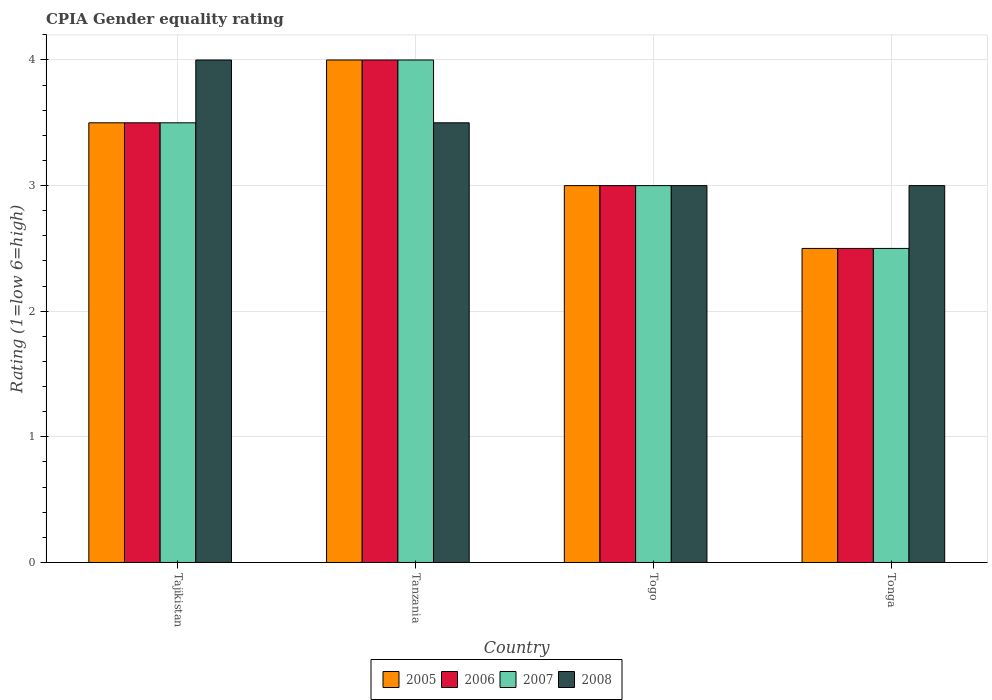How many groups of bars are there?
Give a very brief answer. 4. Are the number of bars per tick equal to the number of legend labels?
Ensure brevity in your answer.  Yes. Are the number of bars on each tick of the X-axis equal?
Your answer should be compact. Yes. How many bars are there on the 3rd tick from the left?
Your answer should be very brief. 4. What is the label of the 3rd group of bars from the left?
Your answer should be compact. Togo. What is the CPIA rating in 2006 in Togo?
Offer a very short reply. 3. Across all countries, what is the minimum CPIA rating in 2007?
Your answer should be very brief. 2.5. In which country was the CPIA rating in 2007 maximum?
Provide a short and direct response. Tanzania. In which country was the CPIA rating in 2005 minimum?
Your answer should be compact. Tonga. What is the difference between the CPIA rating in 2005 in Tajikistan and that in Tanzania?
Make the answer very short. -0.5. What is the average CPIA rating in 2008 per country?
Provide a short and direct response. 3.38. What is the difference between the CPIA rating of/in 2006 and CPIA rating of/in 2008 in Togo?
Your response must be concise. 0. In how many countries, is the CPIA rating in 2005 greater than 2.8?
Your response must be concise. 3. Is the difference between the CPIA rating in 2006 in Tajikistan and Tanzania greater than the difference between the CPIA rating in 2008 in Tajikistan and Tanzania?
Provide a succinct answer. No. What is the difference between the highest and the second highest CPIA rating in 2005?
Offer a terse response. -0.5. In how many countries, is the CPIA rating in 2007 greater than the average CPIA rating in 2007 taken over all countries?
Your answer should be very brief. 2. Is the sum of the CPIA rating in 2005 in Tanzania and Tonga greater than the maximum CPIA rating in 2007 across all countries?
Offer a very short reply. Yes. Is it the case that in every country, the sum of the CPIA rating in 2008 and CPIA rating in 2007 is greater than the sum of CPIA rating in 2005 and CPIA rating in 2006?
Keep it short and to the point. No. What does the 2nd bar from the left in Tanzania represents?
Keep it short and to the point. 2006. What does the 1st bar from the right in Tonga represents?
Provide a short and direct response. 2008. How many bars are there?
Give a very brief answer. 16. How many countries are there in the graph?
Offer a very short reply. 4. What is the difference between two consecutive major ticks on the Y-axis?
Make the answer very short. 1. Are the values on the major ticks of Y-axis written in scientific E-notation?
Offer a very short reply. No. Does the graph contain any zero values?
Your response must be concise. No. What is the title of the graph?
Give a very brief answer. CPIA Gender equality rating. Does "1989" appear as one of the legend labels in the graph?
Give a very brief answer. No. What is the label or title of the X-axis?
Your response must be concise. Country. What is the Rating (1=low 6=high) in 2005 in Tajikistan?
Your answer should be compact. 3.5. What is the Rating (1=low 6=high) in 2008 in Tajikistan?
Keep it short and to the point. 4. What is the Rating (1=low 6=high) in 2005 in Tanzania?
Keep it short and to the point. 4. What is the Rating (1=low 6=high) in 2007 in Tanzania?
Offer a terse response. 4. What is the Rating (1=low 6=high) in 2005 in Tonga?
Your answer should be compact. 2.5. What is the Rating (1=low 6=high) of 2008 in Tonga?
Ensure brevity in your answer.  3. Across all countries, what is the maximum Rating (1=low 6=high) in 2005?
Offer a very short reply. 4. Across all countries, what is the maximum Rating (1=low 6=high) of 2007?
Make the answer very short. 4. Across all countries, what is the maximum Rating (1=low 6=high) in 2008?
Make the answer very short. 4. Across all countries, what is the minimum Rating (1=low 6=high) in 2005?
Provide a succinct answer. 2.5. Across all countries, what is the minimum Rating (1=low 6=high) of 2006?
Ensure brevity in your answer.  2.5. Across all countries, what is the minimum Rating (1=low 6=high) of 2007?
Provide a succinct answer. 2.5. What is the total Rating (1=low 6=high) in 2005 in the graph?
Your answer should be compact. 13. What is the total Rating (1=low 6=high) in 2007 in the graph?
Give a very brief answer. 13. What is the difference between the Rating (1=low 6=high) in 2006 in Tajikistan and that in Tanzania?
Provide a succinct answer. -0.5. What is the difference between the Rating (1=low 6=high) of 2008 in Tajikistan and that in Tanzania?
Your answer should be compact. 0.5. What is the difference between the Rating (1=low 6=high) of 2005 in Tajikistan and that in Togo?
Provide a short and direct response. 0.5. What is the difference between the Rating (1=low 6=high) of 2006 in Tajikistan and that in Togo?
Provide a short and direct response. 0.5. What is the difference between the Rating (1=low 6=high) in 2007 in Tajikistan and that in Togo?
Your response must be concise. 0.5. What is the difference between the Rating (1=low 6=high) in 2008 in Tajikistan and that in Togo?
Your answer should be compact. 1. What is the difference between the Rating (1=low 6=high) in 2005 in Tajikistan and that in Tonga?
Offer a very short reply. 1. What is the difference between the Rating (1=low 6=high) in 2006 in Tajikistan and that in Tonga?
Give a very brief answer. 1. What is the difference between the Rating (1=low 6=high) in 2007 in Tajikistan and that in Tonga?
Ensure brevity in your answer.  1. What is the difference between the Rating (1=low 6=high) in 2008 in Tajikistan and that in Tonga?
Make the answer very short. 1. What is the difference between the Rating (1=low 6=high) in 2005 in Tanzania and that in Togo?
Offer a terse response. 1. What is the difference between the Rating (1=low 6=high) in 2006 in Tanzania and that in Togo?
Give a very brief answer. 1. What is the difference between the Rating (1=low 6=high) of 2007 in Tanzania and that in Togo?
Give a very brief answer. 1. What is the difference between the Rating (1=low 6=high) in 2008 in Tanzania and that in Togo?
Provide a succinct answer. 0.5. What is the difference between the Rating (1=low 6=high) of 2007 in Tanzania and that in Tonga?
Provide a short and direct response. 1.5. What is the difference between the Rating (1=low 6=high) of 2008 in Tanzania and that in Tonga?
Provide a short and direct response. 0.5. What is the difference between the Rating (1=low 6=high) of 2006 in Togo and that in Tonga?
Provide a succinct answer. 0.5. What is the difference between the Rating (1=low 6=high) in 2007 in Togo and that in Tonga?
Keep it short and to the point. 0.5. What is the difference between the Rating (1=low 6=high) in 2008 in Togo and that in Tonga?
Ensure brevity in your answer.  0. What is the difference between the Rating (1=low 6=high) of 2005 in Tajikistan and the Rating (1=low 6=high) of 2006 in Tanzania?
Ensure brevity in your answer.  -0.5. What is the difference between the Rating (1=low 6=high) in 2005 in Tajikistan and the Rating (1=low 6=high) in 2008 in Tanzania?
Provide a succinct answer. 0. What is the difference between the Rating (1=low 6=high) in 2006 in Tajikistan and the Rating (1=low 6=high) in 2008 in Tanzania?
Ensure brevity in your answer.  0. What is the difference between the Rating (1=low 6=high) in 2007 in Tajikistan and the Rating (1=low 6=high) in 2008 in Tanzania?
Provide a short and direct response. 0. What is the difference between the Rating (1=low 6=high) in 2005 in Tajikistan and the Rating (1=low 6=high) in 2008 in Togo?
Make the answer very short. 0.5. What is the difference between the Rating (1=low 6=high) of 2006 in Tajikistan and the Rating (1=low 6=high) of 2007 in Togo?
Your answer should be very brief. 0.5. What is the difference between the Rating (1=low 6=high) of 2006 in Tajikistan and the Rating (1=low 6=high) of 2008 in Togo?
Provide a short and direct response. 0.5. What is the difference between the Rating (1=low 6=high) of 2005 in Tajikistan and the Rating (1=low 6=high) of 2007 in Tonga?
Your response must be concise. 1. What is the difference between the Rating (1=low 6=high) of 2005 in Tajikistan and the Rating (1=low 6=high) of 2008 in Tonga?
Your answer should be compact. 0.5. What is the difference between the Rating (1=low 6=high) of 2006 in Tajikistan and the Rating (1=low 6=high) of 2008 in Tonga?
Provide a short and direct response. 0.5. What is the difference between the Rating (1=low 6=high) of 2007 in Tajikistan and the Rating (1=low 6=high) of 2008 in Tonga?
Keep it short and to the point. 0.5. What is the difference between the Rating (1=low 6=high) in 2005 in Tanzania and the Rating (1=low 6=high) in 2006 in Togo?
Your answer should be compact. 1. What is the difference between the Rating (1=low 6=high) of 2005 in Tanzania and the Rating (1=low 6=high) of 2007 in Togo?
Make the answer very short. 1. What is the difference between the Rating (1=low 6=high) in 2005 in Tanzania and the Rating (1=low 6=high) in 2008 in Togo?
Keep it short and to the point. 1. What is the difference between the Rating (1=low 6=high) of 2006 in Tanzania and the Rating (1=low 6=high) of 2008 in Togo?
Give a very brief answer. 1. What is the difference between the Rating (1=low 6=high) in 2007 in Tanzania and the Rating (1=low 6=high) in 2008 in Togo?
Provide a short and direct response. 1. What is the difference between the Rating (1=low 6=high) in 2005 in Tanzania and the Rating (1=low 6=high) in 2007 in Tonga?
Give a very brief answer. 1.5. What is the difference between the Rating (1=low 6=high) in 2005 in Tanzania and the Rating (1=low 6=high) in 2008 in Tonga?
Ensure brevity in your answer.  1. What is the difference between the Rating (1=low 6=high) of 2006 in Tanzania and the Rating (1=low 6=high) of 2008 in Tonga?
Keep it short and to the point. 1. What is the difference between the Rating (1=low 6=high) in 2007 in Tanzania and the Rating (1=low 6=high) in 2008 in Tonga?
Make the answer very short. 1. What is the difference between the Rating (1=low 6=high) of 2005 in Togo and the Rating (1=low 6=high) of 2006 in Tonga?
Offer a terse response. 0.5. What is the difference between the Rating (1=low 6=high) in 2006 in Togo and the Rating (1=low 6=high) in 2007 in Tonga?
Ensure brevity in your answer.  0.5. What is the difference between the Rating (1=low 6=high) in 2006 in Togo and the Rating (1=low 6=high) in 2008 in Tonga?
Ensure brevity in your answer.  0. What is the average Rating (1=low 6=high) in 2006 per country?
Your response must be concise. 3.25. What is the average Rating (1=low 6=high) in 2008 per country?
Keep it short and to the point. 3.38. What is the difference between the Rating (1=low 6=high) of 2006 and Rating (1=low 6=high) of 2007 in Tajikistan?
Offer a terse response. 0. What is the difference between the Rating (1=low 6=high) of 2007 and Rating (1=low 6=high) of 2008 in Tajikistan?
Your answer should be compact. -0.5. What is the difference between the Rating (1=low 6=high) of 2005 and Rating (1=low 6=high) of 2007 in Tanzania?
Ensure brevity in your answer.  0. What is the difference between the Rating (1=low 6=high) of 2006 and Rating (1=low 6=high) of 2007 in Togo?
Offer a terse response. 0. What is the difference between the Rating (1=low 6=high) of 2005 and Rating (1=low 6=high) of 2006 in Tonga?
Provide a short and direct response. 0. What is the difference between the Rating (1=low 6=high) of 2005 and Rating (1=low 6=high) of 2007 in Tonga?
Make the answer very short. 0. What is the difference between the Rating (1=low 6=high) of 2005 and Rating (1=low 6=high) of 2008 in Tonga?
Your response must be concise. -0.5. What is the difference between the Rating (1=low 6=high) of 2006 and Rating (1=low 6=high) of 2007 in Tonga?
Ensure brevity in your answer.  0. What is the ratio of the Rating (1=low 6=high) in 2005 in Tajikistan to that in Tanzania?
Ensure brevity in your answer.  0.88. What is the ratio of the Rating (1=low 6=high) in 2006 in Tajikistan to that in Tanzania?
Your response must be concise. 0.88. What is the ratio of the Rating (1=low 6=high) in 2007 in Tajikistan to that in Tanzania?
Your response must be concise. 0.88. What is the ratio of the Rating (1=low 6=high) of 2008 in Tajikistan to that in Tanzania?
Make the answer very short. 1.14. What is the ratio of the Rating (1=low 6=high) of 2007 in Tajikistan to that in Togo?
Give a very brief answer. 1.17. What is the ratio of the Rating (1=low 6=high) in 2005 in Tajikistan to that in Tonga?
Your answer should be very brief. 1.4. What is the ratio of the Rating (1=low 6=high) in 2007 in Tajikistan to that in Tonga?
Keep it short and to the point. 1.4. What is the ratio of the Rating (1=low 6=high) of 2008 in Tajikistan to that in Tonga?
Offer a very short reply. 1.33. What is the ratio of the Rating (1=low 6=high) in 2005 in Tanzania to that in Togo?
Your answer should be very brief. 1.33. What is the ratio of the Rating (1=low 6=high) of 2007 in Tanzania to that in Togo?
Your answer should be compact. 1.33. What is the ratio of the Rating (1=low 6=high) of 2008 in Tanzania to that in Togo?
Provide a succinct answer. 1.17. What is the ratio of the Rating (1=low 6=high) of 2005 in Tanzania to that in Tonga?
Your answer should be very brief. 1.6. What is the ratio of the Rating (1=low 6=high) of 2006 in Tanzania to that in Tonga?
Give a very brief answer. 1.6. What is the ratio of the Rating (1=low 6=high) of 2007 in Tanzania to that in Tonga?
Offer a terse response. 1.6. What is the ratio of the Rating (1=low 6=high) in 2007 in Togo to that in Tonga?
Your answer should be compact. 1.2. What is the difference between the highest and the second highest Rating (1=low 6=high) of 2005?
Keep it short and to the point. 0.5. What is the difference between the highest and the lowest Rating (1=low 6=high) of 2007?
Give a very brief answer. 1.5. 